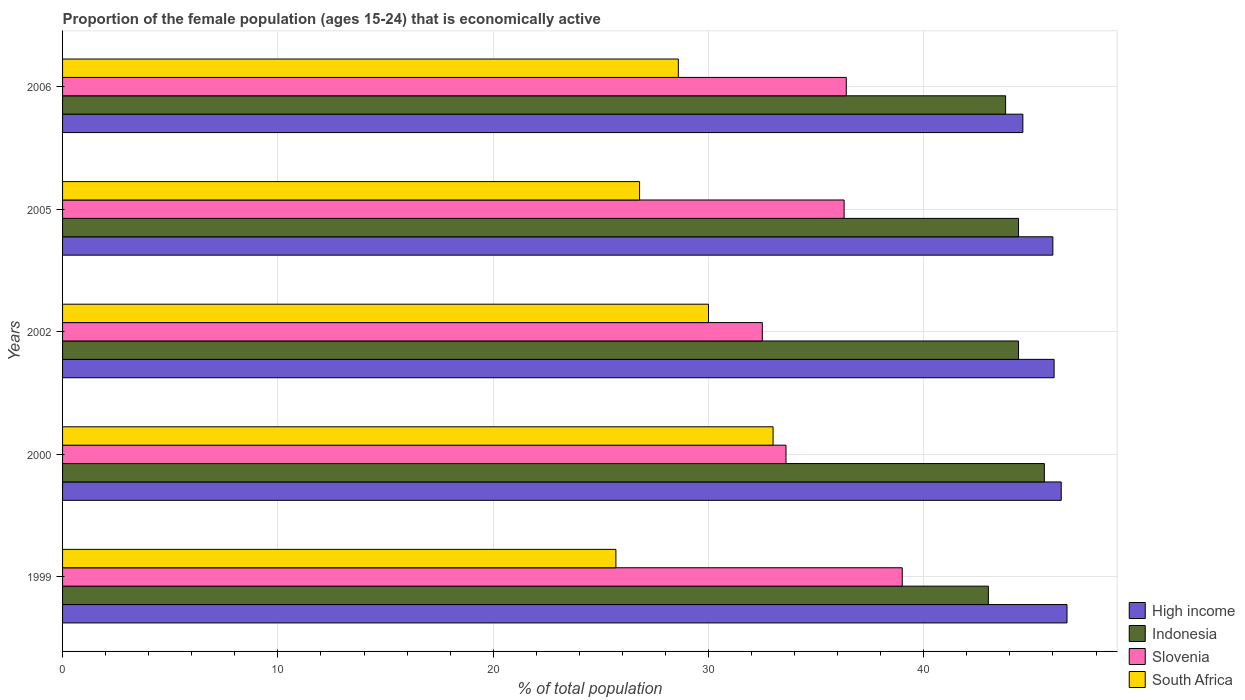How many groups of bars are there?
Provide a short and direct response. 5. Are the number of bars per tick equal to the number of legend labels?
Provide a short and direct response. Yes. Are the number of bars on each tick of the Y-axis equal?
Your answer should be very brief. Yes. In how many cases, is the number of bars for a given year not equal to the number of legend labels?
Offer a very short reply. 0. Across all years, what is the maximum proportion of the female population that is economically active in Indonesia?
Provide a succinct answer. 45.6. Across all years, what is the minimum proportion of the female population that is economically active in High income?
Keep it short and to the point. 44.6. In which year was the proportion of the female population that is economically active in South Africa minimum?
Provide a short and direct response. 1999. What is the total proportion of the female population that is economically active in High income in the graph?
Keep it short and to the point. 229.68. What is the difference between the proportion of the female population that is economically active in Indonesia in 2002 and that in 2006?
Your answer should be very brief. 0.6. What is the difference between the proportion of the female population that is economically active in Slovenia in 2000 and the proportion of the female population that is economically active in Indonesia in 2002?
Make the answer very short. -10.8. What is the average proportion of the female population that is economically active in Slovenia per year?
Your answer should be compact. 35.56. In the year 1999, what is the difference between the proportion of the female population that is economically active in Indonesia and proportion of the female population that is economically active in Slovenia?
Your answer should be compact. 4. In how many years, is the proportion of the female population that is economically active in High income greater than 26 %?
Your response must be concise. 5. What is the ratio of the proportion of the female population that is economically active in High income in 1999 to that in 2005?
Ensure brevity in your answer.  1.01. Is the proportion of the female population that is economically active in South Africa in 2002 less than that in 2005?
Make the answer very short. No. Is the difference between the proportion of the female population that is economically active in Indonesia in 2002 and 2005 greater than the difference between the proportion of the female population that is economically active in Slovenia in 2002 and 2005?
Offer a very short reply. Yes. What is the difference between the highest and the second highest proportion of the female population that is economically active in Slovenia?
Offer a very short reply. 2.6. What is the difference between the highest and the lowest proportion of the female population that is economically active in South Africa?
Your response must be concise. 7.3. Is it the case that in every year, the sum of the proportion of the female population that is economically active in South Africa and proportion of the female population that is economically active in High income is greater than the sum of proportion of the female population that is economically active in Indonesia and proportion of the female population that is economically active in Slovenia?
Provide a short and direct response. Yes. What does the 2nd bar from the top in 2000 represents?
Your answer should be very brief. Slovenia. What does the 3rd bar from the bottom in 2005 represents?
Your answer should be very brief. Slovenia. Are all the bars in the graph horizontal?
Your answer should be very brief. Yes. How many years are there in the graph?
Your answer should be very brief. 5. Are the values on the major ticks of X-axis written in scientific E-notation?
Offer a very short reply. No. Does the graph contain any zero values?
Offer a very short reply. No. Does the graph contain grids?
Give a very brief answer. Yes. How are the legend labels stacked?
Offer a terse response. Vertical. What is the title of the graph?
Offer a terse response. Proportion of the female population (ages 15-24) that is economically active. What is the label or title of the X-axis?
Offer a terse response. % of total population. What is the label or title of the Y-axis?
Keep it short and to the point. Years. What is the % of total population of High income in 1999?
Provide a succinct answer. 46.65. What is the % of total population in Indonesia in 1999?
Offer a terse response. 43. What is the % of total population in South Africa in 1999?
Provide a succinct answer. 25.7. What is the % of total population of High income in 2000?
Give a very brief answer. 46.38. What is the % of total population of Indonesia in 2000?
Your answer should be very brief. 45.6. What is the % of total population in Slovenia in 2000?
Provide a succinct answer. 33.6. What is the % of total population of South Africa in 2000?
Give a very brief answer. 33. What is the % of total population of High income in 2002?
Keep it short and to the point. 46.05. What is the % of total population of Indonesia in 2002?
Offer a terse response. 44.4. What is the % of total population of Slovenia in 2002?
Your answer should be very brief. 32.5. What is the % of total population in High income in 2005?
Give a very brief answer. 45.99. What is the % of total population of Indonesia in 2005?
Your response must be concise. 44.4. What is the % of total population of Slovenia in 2005?
Your response must be concise. 36.3. What is the % of total population in South Africa in 2005?
Offer a very short reply. 26.8. What is the % of total population of High income in 2006?
Make the answer very short. 44.6. What is the % of total population of Indonesia in 2006?
Your answer should be very brief. 43.8. What is the % of total population in Slovenia in 2006?
Keep it short and to the point. 36.4. What is the % of total population of South Africa in 2006?
Give a very brief answer. 28.6. Across all years, what is the maximum % of total population in High income?
Ensure brevity in your answer.  46.65. Across all years, what is the maximum % of total population in Indonesia?
Keep it short and to the point. 45.6. Across all years, what is the maximum % of total population in South Africa?
Your response must be concise. 33. Across all years, what is the minimum % of total population in High income?
Your answer should be compact. 44.6. Across all years, what is the minimum % of total population of Indonesia?
Provide a succinct answer. 43. Across all years, what is the minimum % of total population of Slovenia?
Offer a terse response. 32.5. Across all years, what is the minimum % of total population of South Africa?
Keep it short and to the point. 25.7. What is the total % of total population in High income in the graph?
Offer a very short reply. 229.68. What is the total % of total population of Indonesia in the graph?
Offer a terse response. 221.2. What is the total % of total population in Slovenia in the graph?
Provide a succinct answer. 177.8. What is the total % of total population of South Africa in the graph?
Your answer should be compact. 144.1. What is the difference between the % of total population of High income in 1999 and that in 2000?
Your answer should be compact. 0.27. What is the difference between the % of total population in Slovenia in 1999 and that in 2000?
Your answer should be very brief. 5.4. What is the difference between the % of total population in High income in 1999 and that in 2002?
Your answer should be compact. 0.6. What is the difference between the % of total population of Indonesia in 1999 and that in 2002?
Ensure brevity in your answer.  -1.4. What is the difference between the % of total population in Slovenia in 1999 and that in 2002?
Provide a succinct answer. 6.5. What is the difference between the % of total population in High income in 1999 and that in 2005?
Ensure brevity in your answer.  0.66. What is the difference between the % of total population in Slovenia in 1999 and that in 2005?
Provide a short and direct response. 2.7. What is the difference between the % of total population of South Africa in 1999 and that in 2005?
Make the answer very short. -1.1. What is the difference between the % of total population of High income in 1999 and that in 2006?
Offer a very short reply. 2.05. What is the difference between the % of total population of South Africa in 1999 and that in 2006?
Provide a succinct answer. -2.9. What is the difference between the % of total population in High income in 2000 and that in 2002?
Provide a short and direct response. 0.33. What is the difference between the % of total population in Slovenia in 2000 and that in 2002?
Give a very brief answer. 1.1. What is the difference between the % of total population of High income in 2000 and that in 2005?
Provide a succinct answer. 0.39. What is the difference between the % of total population of Indonesia in 2000 and that in 2005?
Provide a succinct answer. 1.2. What is the difference between the % of total population in Slovenia in 2000 and that in 2005?
Provide a succinct answer. -2.7. What is the difference between the % of total population of High income in 2000 and that in 2006?
Offer a terse response. 1.78. What is the difference between the % of total population in Indonesia in 2000 and that in 2006?
Your answer should be very brief. 1.8. What is the difference between the % of total population of Slovenia in 2000 and that in 2006?
Your answer should be very brief. -2.8. What is the difference between the % of total population of High income in 2002 and that in 2005?
Keep it short and to the point. 0.06. What is the difference between the % of total population in Indonesia in 2002 and that in 2005?
Give a very brief answer. 0. What is the difference between the % of total population in South Africa in 2002 and that in 2005?
Your response must be concise. 3.2. What is the difference between the % of total population of High income in 2002 and that in 2006?
Your response must be concise. 1.45. What is the difference between the % of total population in High income in 2005 and that in 2006?
Your answer should be compact. 1.39. What is the difference between the % of total population in Slovenia in 2005 and that in 2006?
Give a very brief answer. -0.1. What is the difference between the % of total population in South Africa in 2005 and that in 2006?
Your answer should be compact. -1.8. What is the difference between the % of total population of High income in 1999 and the % of total population of Indonesia in 2000?
Provide a succinct answer. 1.05. What is the difference between the % of total population of High income in 1999 and the % of total population of Slovenia in 2000?
Your answer should be very brief. 13.05. What is the difference between the % of total population in High income in 1999 and the % of total population in South Africa in 2000?
Provide a short and direct response. 13.65. What is the difference between the % of total population of Indonesia in 1999 and the % of total population of Slovenia in 2000?
Your answer should be very brief. 9.4. What is the difference between the % of total population in High income in 1999 and the % of total population in Indonesia in 2002?
Your answer should be compact. 2.25. What is the difference between the % of total population in High income in 1999 and the % of total population in Slovenia in 2002?
Offer a very short reply. 14.15. What is the difference between the % of total population in High income in 1999 and the % of total population in South Africa in 2002?
Keep it short and to the point. 16.65. What is the difference between the % of total population of Indonesia in 1999 and the % of total population of Slovenia in 2002?
Your answer should be very brief. 10.5. What is the difference between the % of total population of High income in 1999 and the % of total population of Indonesia in 2005?
Offer a very short reply. 2.25. What is the difference between the % of total population of High income in 1999 and the % of total population of Slovenia in 2005?
Offer a very short reply. 10.35. What is the difference between the % of total population in High income in 1999 and the % of total population in South Africa in 2005?
Offer a very short reply. 19.85. What is the difference between the % of total population of Indonesia in 1999 and the % of total population of South Africa in 2005?
Make the answer very short. 16.2. What is the difference between the % of total population in High income in 1999 and the % of total population in Indonesia in 2006?
Offer a very short reply. 2.85. What is the difference between the % of total population of High income in 1999 and the % of total population of Slovenia in 2006?
Ensure brevity in your answer.  10.25. What is the difference between the % of total population of High income in 1999 and the % of total population of South Africa in 2006?
Offer a very short reply. 18.05. What is the difference between the % of total population in Slovenia in 1999 and the % of total population in South Africa in 2006?
Give a very brief answer. 10.4. What is the difference between the % of total population in High income in 2000 and the % of total population in Indonesia in 2002?
Offer a very short reply. 1.98. What is the difference between the % of total population in High income in 2000 and the % of total population in Slovenia in 2002?
Provide a succinct answer. 13.88. What is the difference between the % of total population of High income in 2000 and the % of total population of South Africa in 2002?
Provide a succinct answer. 16.38. What is the difference between the % of total population in Indonesia in 2000 and the % of total population in Slovenia in 2002?
Make the answer very short. 13.1. What is the difference between the % of total population in Indonesia in 2000 and the % of total population in South Africa in 2002?
Your response must be concise. 15.6. What is the difference between the % of total population in High income in 2000 and the % of total population in Indonesia in 2005?
Make the answer very short. 1.98. What is the difference between the % of total population of High income in 2000 and the % of total population of Slovenia in 2005?
Your response must be concise. 10.08. What is the difference between the % of total population in High income in 2000 and the % of total population in South Africa in 2005?
Ensure brevity in your answer.  19.58. What is the difference between the % of total population of Slovenia in 2000 and the % of total population of South Africa in 2005?
Provide a succinct answer. 6.8. What is the difference between the % of total population of High income in 2000 and the % of total population of Indonesia in 2006?
Offer a very short reply. 2.58. What is the difference between the % of total population in High income in 2000 and the % of total population in Slovenia in 2006?
Your answer should be very brief. 9.98. What is the difference between the % of total population in High income in 2000 and the % of total population in South Africa in 2006?
Your answer should be compact. 17.78. What is the difference between the % of total population of High income in 2002 and the % of total population of Indonesia in 2005?
Provide a succinct answer. 1.65. What is the difference between the % of total population of High income in 2002 and the % of total population of Slovenia in 2005?
Your response must be concise. 9.75. What is the difference between the % of total population of High income in 2002 and the % of total population of South Africa in 2005?
Give a very brief answer. 19.25. What is the difference between the % of total population of Indonesia in 2002 and the % of total population of Slovenia in 2005?
Give a very brief answer. 8.1. What is the difference between the % of total population in Indonesia in 2002 and the % of total population in South Africa in 2005?
Offer a very short reply. 17.6. What is the difference between the % of total population in High income in 2002 and the % of total population in Indonesia in 2006?
Provide a succinct answer. 2.25. What is the difference between the % of total population of High income in 2002 and the % of total population of Slovenia in 2006?
Your answer should be compact. 9.65. What is the difference between the % of total population in High income in 2002 and the % of total population in South Africa in 2006?
Offer a terse response. 17.45. What is the difference between the % of total population of Indonesia in 2002 and the % of total population of Slovenia in 2006?
Offer a very short reply. 8. What is the difference between the % of total population in Slovenia in 2002 and the % of total population in South Africa in 2006?
Provide a succinct answer. 3.9. What is the difference between the % of total population in High income in 2005 and the % of total population in Indonesia in 2006?
Your answer should be very brief. 2.19. What is the difference between the % of total population in High income in 2005 and the % of total population in Slovenia in 2006?
Give a very brief answer. 9.59. What is the difference between the % of total population of High income in 2005 and the % of total population of South Africa in 2006?
Your answer should be very brief. 17.39. What is the difference between the % of total population in Slovenia in 2005 and the % of total population in South Africa in 2006?
Your response must be concise. 7.7. What is the average % of total population in High income per year?
Your response must be concise. 45.94. What is the average % of total population of Indonesia per year?
Your answer should be compact. 44.24. What is the average % of total population in Slovenia per year?
Offer a terse response. 35.56. What is the average % of total population in South Africa per year?
Provide a short and direct response. 28.82. In the year 1999, what is the difference between the % of total population of High income and % of total population of Indonesia?
Provide a short and direct response. 3.65. In the year 1999, what is the difference between the % of total population in High income and % of total population in Slovenia?
Offer a very short reply. 7.65. In the year 1999, what is the difference between the % of total population in High income and % of total population in South Africa?
Offer a very short reply. 20.95. In the year 1999, what is the difference between the % of total population of Indonesia and % of total population of South Africa?
Provide a succinct answer. 17.3. In the year 1999, what is the difference between the % of total population in Slovenia and % of total population in South Africa?
Ensure brevity in your answer.  13.3. In the year 2000, what is the difference between the % of total population of High income and % of total population of Indonesia?
Your answer should be very brief. 0.78. In the year 2000, what is the difference between the % of total population in High income and % of total population in Slovenia?
Your response must be concise. 12.78. In the year 2000, what is the difference between the % of total population in High income and % of total population in South Africa?
Provide a short and direct response. 13.38. In the year 2000, what is the difference between the % of total population of Indonesia and % of total population of Slovenia?
Make the answer very short. 12. In the year 2000, what is the difference between the % of total population in Indonesia and % of total population in South Africa?
Keep it short and to the point. 12.6. In the year 2000, what is the difference between the % of total population of Slovenia and % of total population of South Africa?
Provide a succinct answer. 0.6. In the year 2002, what is the difference between the % of total population in High income and % of total population in Indonesia?
Ensure brevity in your answer.  1.65. In the year 2002, what is the difference between the % of total population in High income and % of total population in Slovenia?
Your answer should be very brief. 13.55. In the year 2002, what is the difference between the % of total population in High income and % of total population in South Africa?
Ensure brevity in your answer.  16.05. In the year 2002, what is the difference between the % of total population of Indonesia and % of total population of South Africa?
Offer a terse response. 14.4. In the year 2002, what is the difference between the % of total population of Slovenia and % of total population of South Africa?
Provide a succinct answer. 2.5. In the year 2005, what is the difference between the % of total population in High income and % of total population in Indonesia?
Ensure brevity in your answer.  1.59. In the year 2005, what is the difference between the % of total population in High income and % of total population in Slovenia?
Your response must be concise. 9.69. In the year 2005, what is the difference between the % of total population in High income and % of total population in South Africa?
Ensure brevity in your answer.  19.19. In the year 2005, what is the difference between the % of total population in Indonesia and % of total population in Slovenia?
Ensure brevity in your answer.  8.1. In the year 2005, what is the difference between the % of total population of Indonesia and % of total population of South Africa?
Ensure brevity in your answer.  17.6. In the year 2005, what is the difference between the % of total population in Slovenia and % of total population in South Africa?
Offer a very short reply. 9.5. In the year 2006, what is the difference between the % of total population in High income and % of total population in Indonesia?
Give a very brief answer. 0.8. In the year 2006, what is the difference between the % of total population of High income and % of total population of Slovenia?
Your answer should be compact. 8.2. In the year 2006, what is the difference between the % of total population in High income and % of total population in South Africa?
Your answer should be compact. 16. In the year 2006, what is the difference between the % of total population in Indonesia and % of total population in Slovenia?
Your response must be concise. 7.4. In the year 2006, what is the difference between the % of total population in Indonesia and % of total population in South Africa?
Provide a short and direct response. 15.2. In the year 2006, what is the difference between the % of total population of Slovenia and % of total population of South Africa?
Your answer should be compact. 7.8. What is the ratio of the % of total population in High income in 1999 to that in 2000?
Provide a short and direct response. 1.01. What is the ratio of the % of total population in Indonesia in 1999 to that in 2000?
Your answer should be very brief. 0.94. What is the ratio of the % of total population in Slovenia in 1999 to that in 2000?
Your answer should be very brief. 1.16. What is the ratio of the % of total population in South Africa in 1999 to that in 2000?
Your answer should be compact. 0.78. What is the ratio of the % of total population of Indonesia in 1999 to that in 2002?
Provide a succinct answer. 0.97. What is the ratio of the % of total population of Slovenia in 1999 to that in 2002?
Ensure brevity in your answer.  1.2. What is the ratio of the % of total population of South Africa in 1999 to that in 2002?
Make the answer very short. 0.86. What is the ratio of the % of total population in High income in 1999 to that in 2005?
Your answer should be compact. 1.01. What is the ratio of the % of total population of Indonesia in 1999 to that in 2005?
Your response must be concise. 0.97. What is the ratio of the % of total population of Slovenia in 1999 to that in 2005?
Offer a terse response. 1.07. What is the ratio of the % of total population of South Africa in 1999 to that in 2005?
Your answer should be compact. 0.96. What is the ratio of the % of total population in High income in 1999 to that in 2006?
Provide a short and direct response. 1.05. What is the ratio of the % of total population of Indonesia in 1999 to that in 2006?
Your response must be concise. 0.98. What is the ratio of the % of total population in Slovenia in 1999 to that in 2006?
Offer a terse response. 1.07. What is the ratio of the % of total population in South Africa in 1999 to that in 2006?
Make the answer very short. 0.9. What is the ratio of the % of total population of Indonesia in 2000 to that in 2002?
Keep it short and to the point. 1.03. What is the ratio of the % of total population in Slovenia in 2000 to that in 2002?
Provide a succinct answer. 1.03. What is the ratio of the % of total population of High income in 2000 to that in 2005?
Give a very brief answer. 1.01. What is the ratio of the % of total population in Slovenia in 2000 to that in 2005?
Ensure brevity in your answer.  0.93. What is the ratio of the % of total population in South Africa in 2000 to that in 2005?
Ensure brevity in your answer.  1.23. What is the ratio of the % of total population of High income in 2000 to that in 2006?
Ensure brevity in your answer.  1.04. What is the ratio of the % of total population of Indonesia in 2000 to that in 2006?
Offer a very short reply. 1.04. What is the ratio of the % of total population of Slovenia in 2000 to that in 2006?
Your answer should be compact. 0.92. What is the ratio of the % of total population in South Africa in 2000 to that in 2006?
Provide a short and direct response. 1.15. What is the ratio of the % of total population of Indonesia in 2002 to that in 2005?
Keep it short and to the point. 1. What is the ratio of the % of total population in Slovenia in 2002 to that in 2005?
Give a very brief answer. 0.9. What is the ratio of the % of total population in South Africa in 2002 to that in 2005?
Your answer should be very brief. 1.12. What is the ratio of the % of total population of High income in 2002 to that in 2006?
Your answer should be compact. 1.03. What is the ratio of the % of total population of Indonesia in 2002 to that in 2006?
Your response must be concise. 1.01. What is the ratio of the % of total population of Slovenia in 2002 to that in 2006?
Provide a short and direct response. 0.89. What is the ratio of the % of total population of South Africa in 2002 to that in 2006?
Your answer should be very brief. 1.05. What is the ratio of the % of total population of High income in 2005 to that in 2006?
Ensure brevity in your answer.  1.03. What is the ratio of the % of total population of Indonesia in 2005 to that in 2006?
Give a very brief answer. 1.01. What is the ratio of the % of total population in South Africa in 2005 to that in 2006?
Offer a terse response. 0.94. What is the difference between the highest and the second highest % of total population in High income?
Offer a very short reply. 0.27. What is the difference between the highest and the second highest % of total population in South Africa?
Ensure brevity in your answer.  3. What is the difference between the highest and the lowest % of total population of High income?
Offer a very short reply. 2.05. What is the difference between the highest and the lowest % of total population of Slovenia?
Provide a succinct answer. 6.5. What is the difference between the highest and the lowest % of total population of South Africa?
Ensure brevity in your answer.  7.3. 